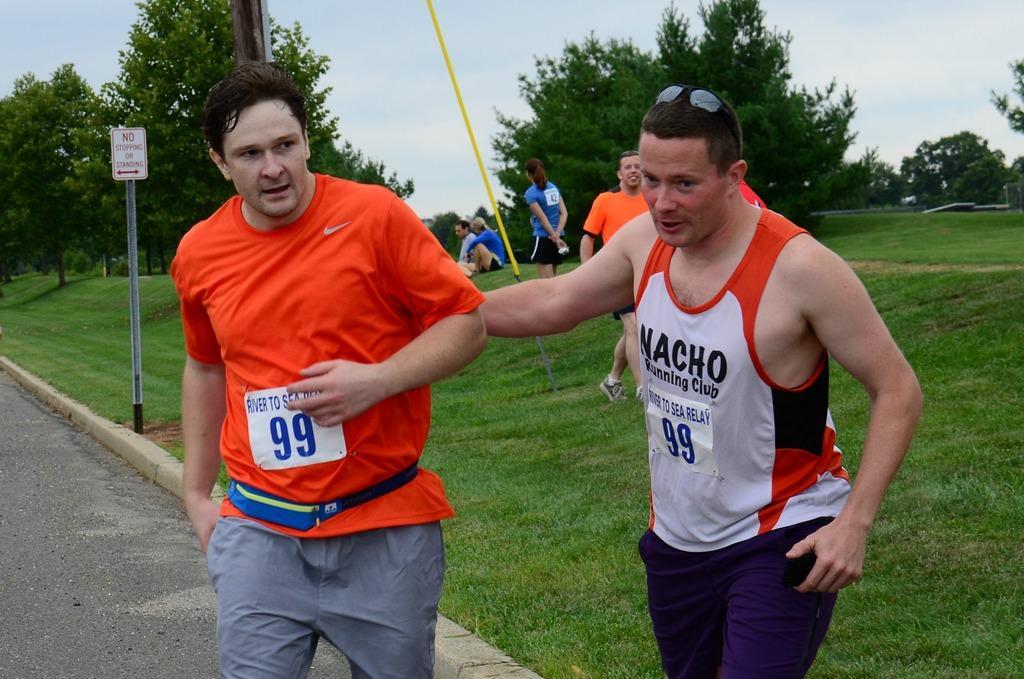How would you summarize this image in a sentence or two? In this image we can see a group of people standing. We can also see two people sitting on the grass field, a signboard to a pole, the pathway, a rope, pole, a group of trees and the sky which looks cloudy. 